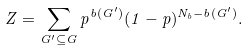<formula> <loc_0><loc_0><loc_500><loc_500>Z = \sum _ { G ^ { \prime } \subseteq G } p ^ { b ( G ^ { \prime } ) } ( 1 - p ) ^ { N _ { b } - b ( G ^ { \prime } ) } .</formula> 